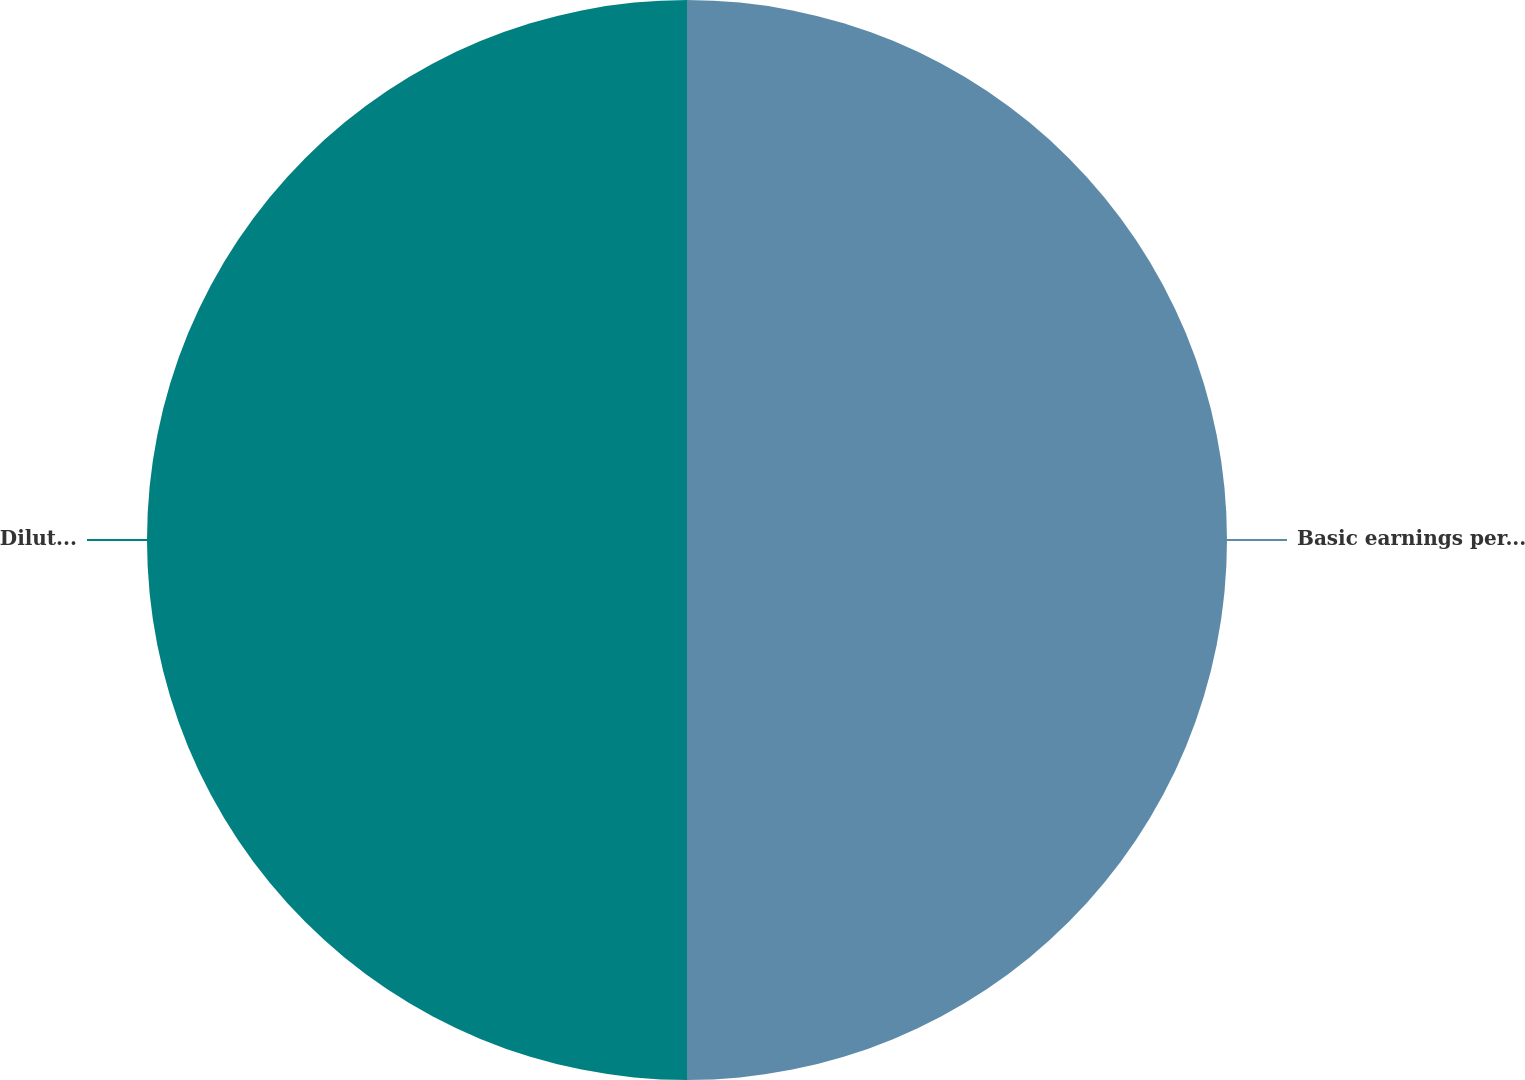Convert chart to OTSL. <chart><loc_0><loc_0><loc_500><loc_500><pie_chart><fcel>Basic earnings per share<fcel>Diluted earnings per share<nl><fcel>50.0%<fcel>50.0%<nl></chart> 